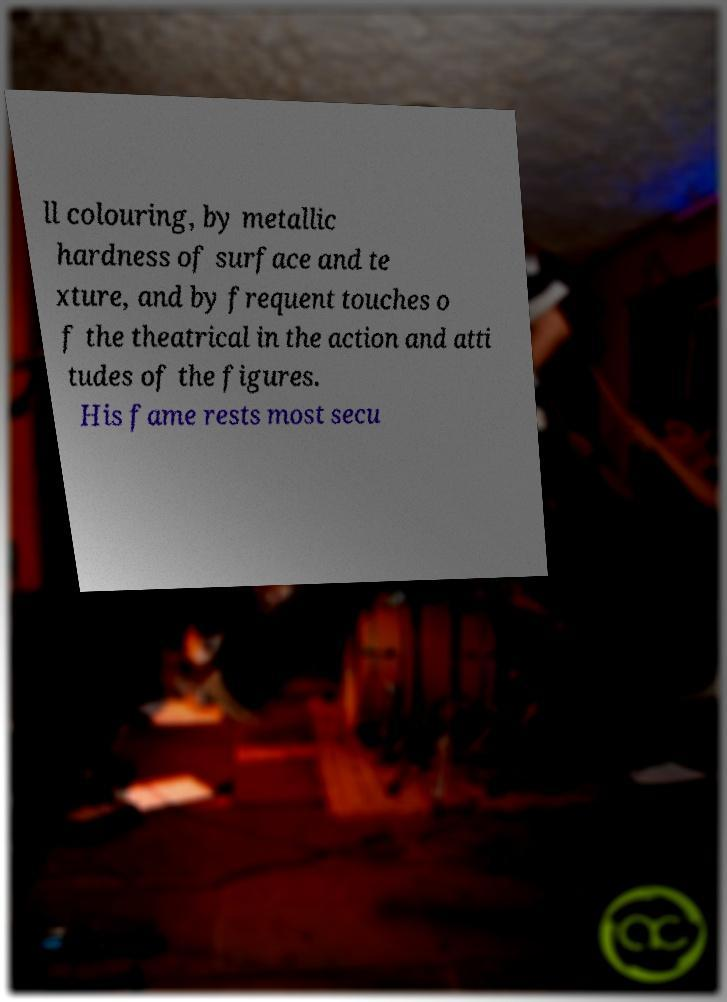There's text embedded in this image that I need extracted. Can you transcribe it verbatim? ll colouring, by metallic hardness of surface and te xture, and by frequent touches o f the theatrical in the action and atti tudes of the figures. His fame rests most secu 